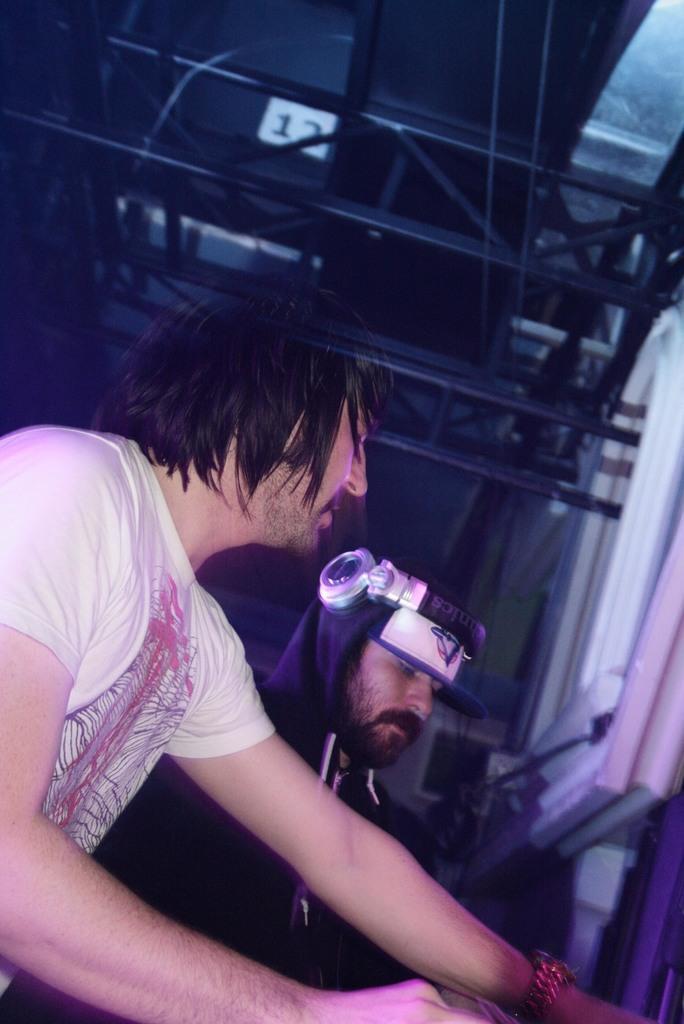Describe this image in one or two sentences. 2 people are present. The person at the front is wearing a white t shirt. 